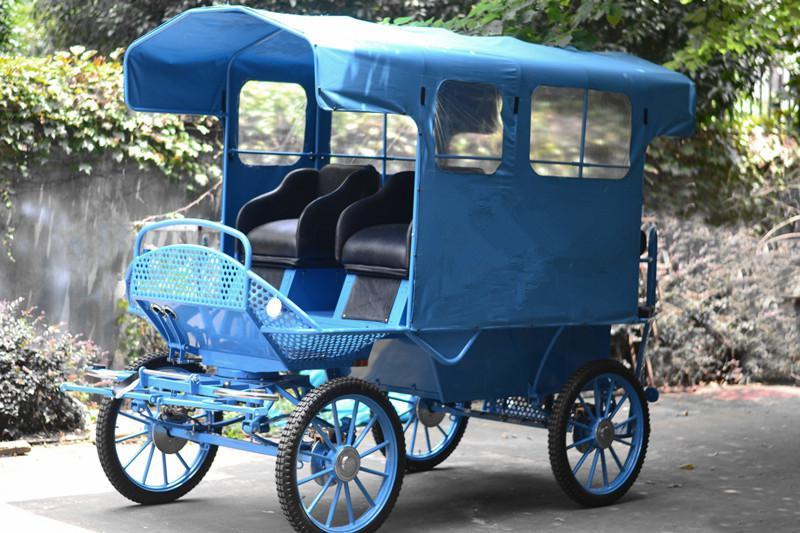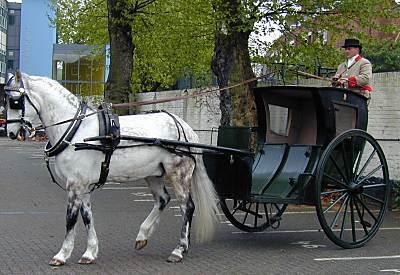The first image is the image on the left, the second image is the image on the right. Evaluate the accuracy of this statement regarding the images: "The carriage is covered in the image on the right.". Is it true? Answer yes or no. Yes. 